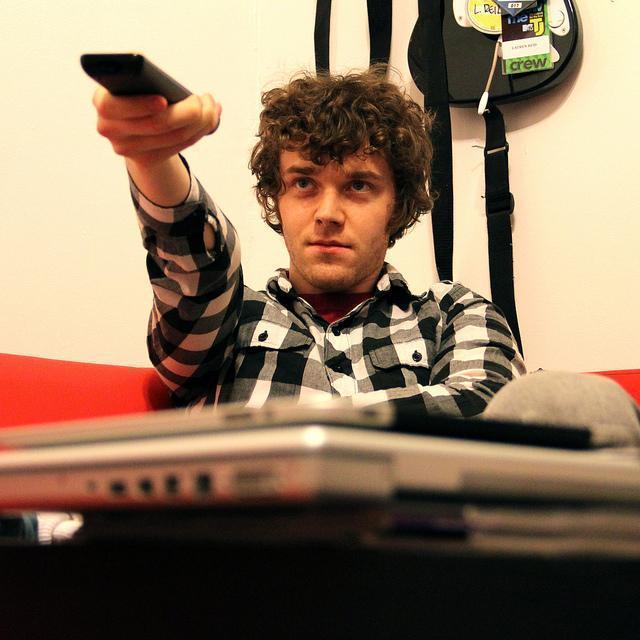How many couches can be seen?
Give a very brief answer. 1. 